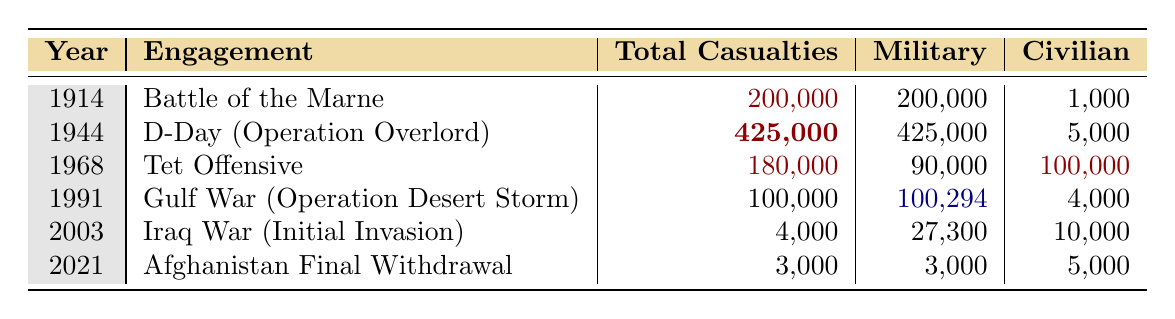What was the total number of casualties in the Battle of the Marne? The table indicates that the total casualties for the Battle of the Marne in 1914 were 200,000.
Answer: 200,000 In which year did D-Day occur? The table shows that D-Day (Operation Overlord) took place in the year 1944.
Answer: 1944 What is the total number of military casualties in the Tet Offensive? The table lists the total military casualties in the Tet Offensive as 90,000, with 50,000 from North Vietnamese, 20,000 from South Vietnamese, and 20,000 from the USA.
Answer: 90,000 Which engagement had the highest civilian casualties? By observing the table, the Tet Offensive had 100,000 civilian casualties, which is higher compared to all other engagements listed.
Answer: Tet Offensive What was the difference in total casualties between the Gulf War and the Iraq War? The total casualties in the Gulf War were 100,000, and in the Iraq War, they were 4,000. The difference is 100,000 - 4,000 = 96,000.
Answer: 96,000 How many total casualties were there in the Iraq War compared to the Afghanistan Final Withdrawal? The Iraq War had 4,000 total casualties and the Afghanistan Final Withdrawal had 3,000. The difference is 4,000 - 3,000 = 1,000, indicating the Iraq War had more casualties.
Answer: 1,000 Did the military casualties in the Gulf War exceed 100,000? The total military casualties in the Gulf War are given as 100,294, which is more than 100,000, making this statement true.
Answer: Yes What is the average number of total casualties from the engagements listed in the table? The total casualties from all engagements are 200,000 + 425,000 + 180,000 + 100,000 + 4,000 + 3,000 = 912,000. There are 6 engagements, so the average is 912,000 / 6 = 152,000.
Answer: 152,000 Which engagement had more total casualties, the D-Day or the Tet Offensive? The D-Day total casualties were 425,000, while the Tet Offensive had 180,000. Since 425,000 is greater than 180,000, D-Day had more total casualties.
Answer: D-Day What was the total military casualties in the Afghanistan Final Withdrawal? The table states that the total military casualties for the Afghanistan Final Withdrawal in 2021 were 3,000.
Answer: 3,000 